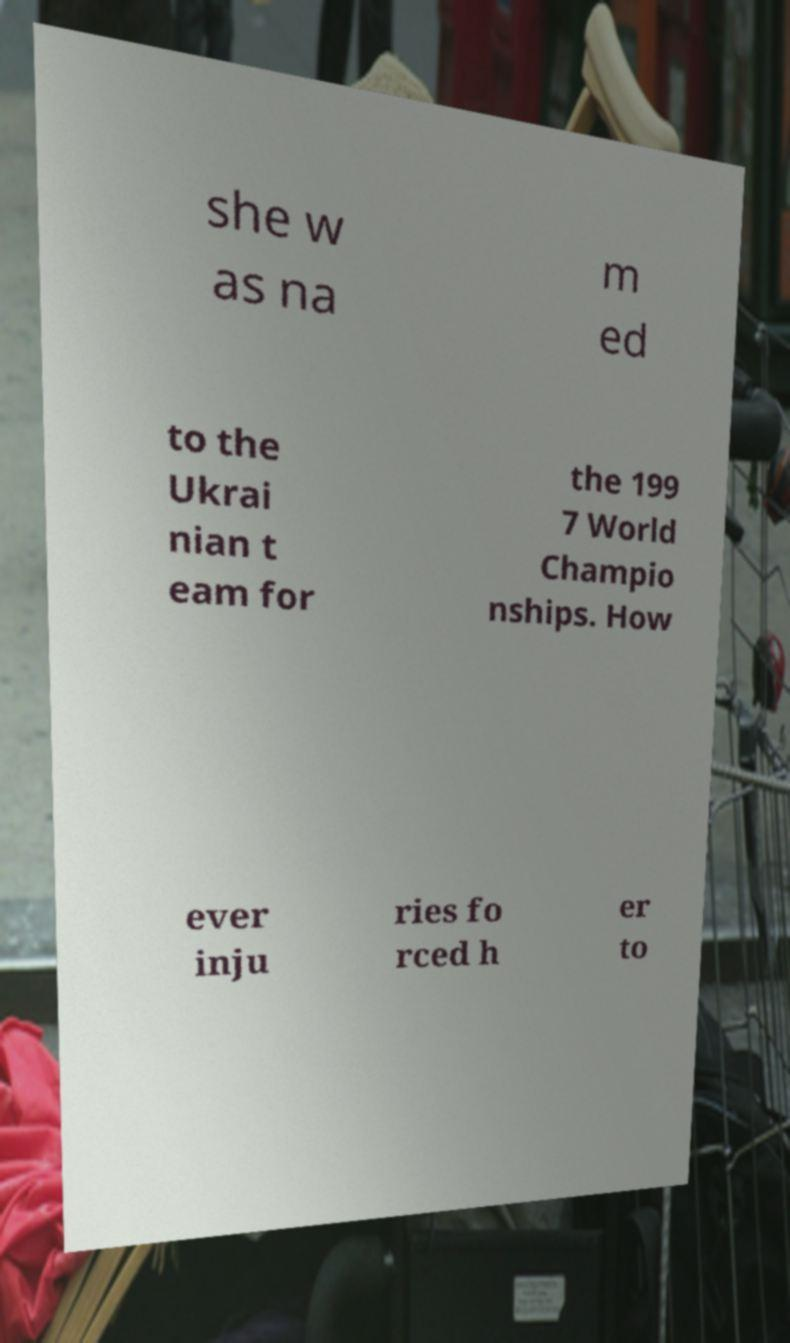Could you extract and type out the text from this image? she w as na m ed to the Ukrai nian t eam for the 199 7 World Champio nships. How ever inju ries fo rced h er to 